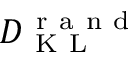<formula> <loc_0><loc_0><loc_500><loc_500>D _ { K L } ^ { r a n d }</formula> 